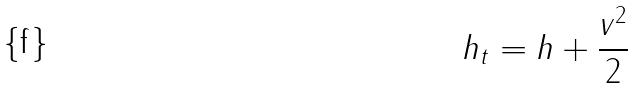<formula> <loc_0><loc_0><loc_500><loc_500>h _ { t } = h + \frac { v ^ { 2 } } { 2 }</formula> 